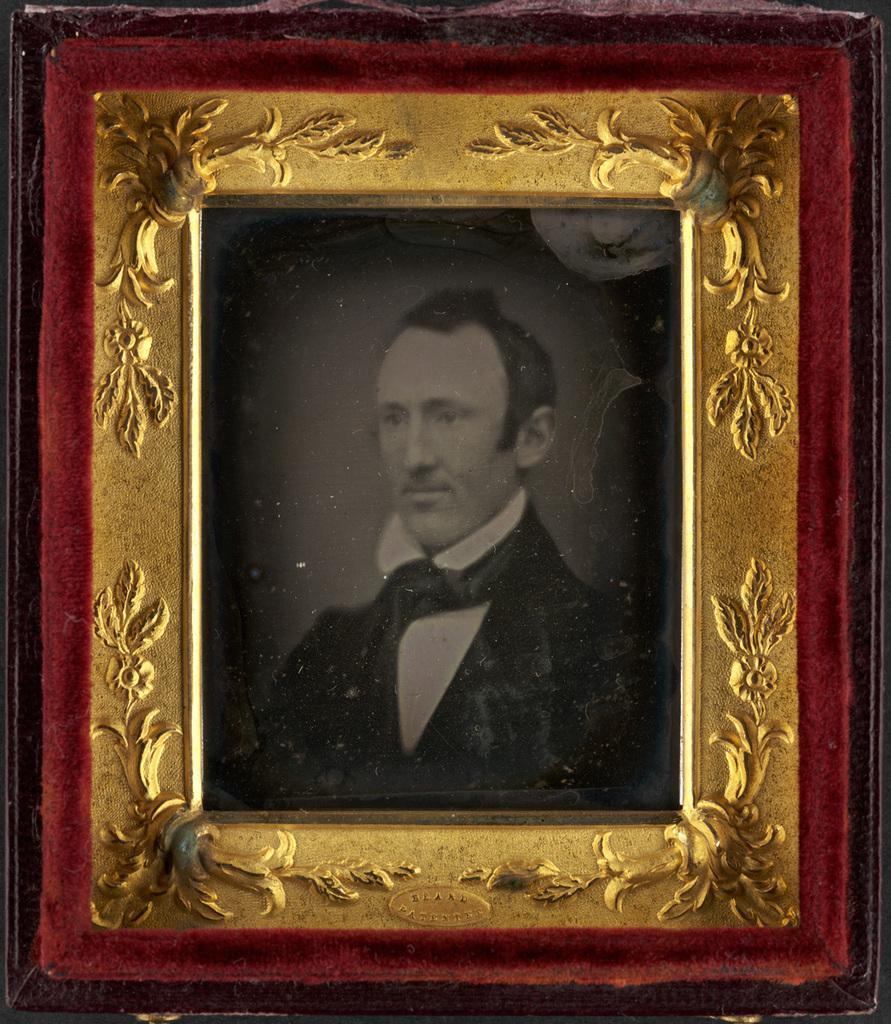How would you summarize this image in a sentence or two? In this picture we can see photo frame. In the photo there is a man who is wearing suit. 